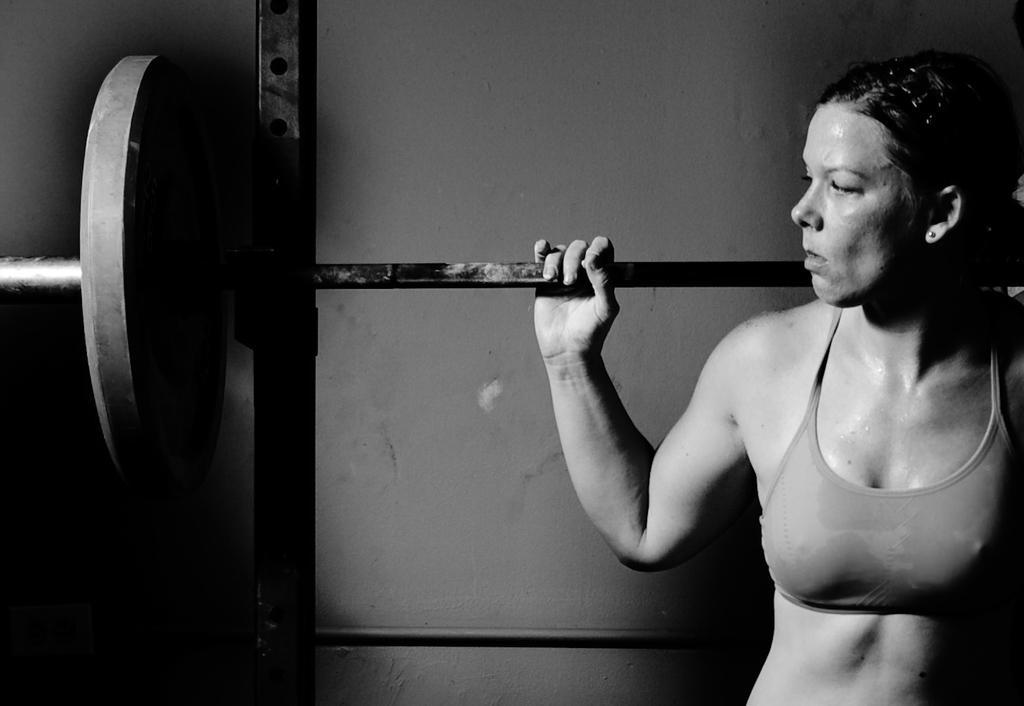Can you describe this image briefly? This is a black and white image. In this image we can see a woman lifting weights on her shoulder. 